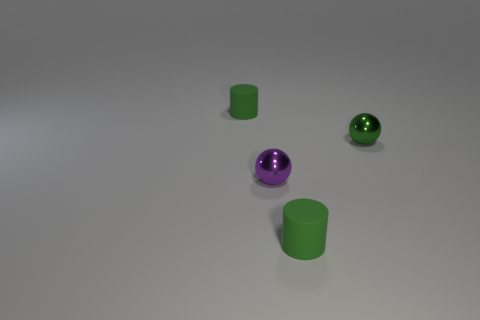Add 3 tiny purple metallic things. How many objects exist? 7 Subtract 1 green cylinders. How many objects are left? 3 Subtract all tiny yellow rubber cylinders. Subtract all purple metallic objects. How many objects are left? 3 Add 1 tiny green matte cylinders. How many tiny green matte cylinders are left? 3 Add 3 big purple shiny cylinders. How many big purple shiny cylinders exist? 3 